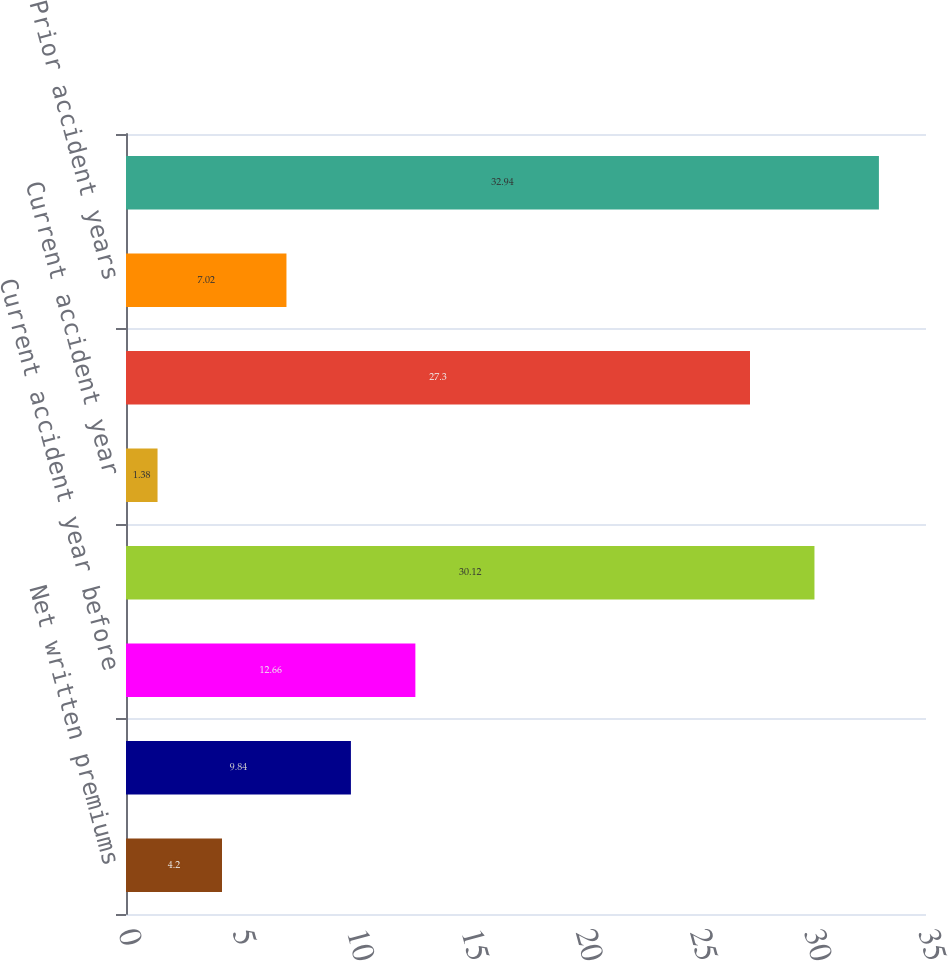Convert chart to OTSL. <chart><loc_0><loc_0><loc_500><loc_500><bar_chart><fcel>Net written premiums<fcel>Earned premiums<fcel>Current accident year before<fcel>Total loss and loss expenses<fcel>Current accident year<fcel>Prior accident years before<fcel>Prior accident years<fcel>Total loss and loss expense<nl><fcel>4.2<fcel>9.84<fcel>12.66<fcel>30.12<fcel>1.38<fcel>27.3<fcel>7.02<fcel>32.94<nl></chart> 